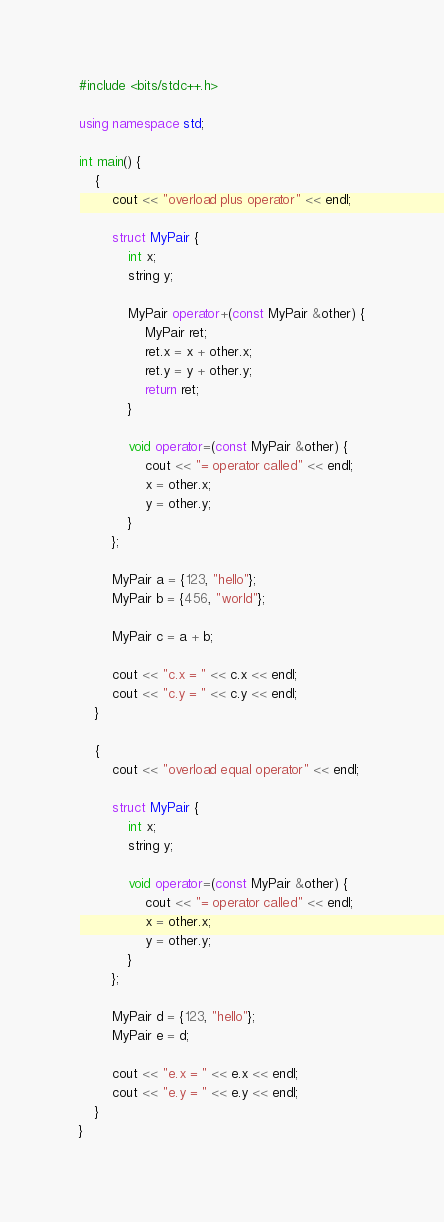<code> <loc_0><loc_0><loc_500><loc_500><_C++_>#include <bits/stdc++.h>

using namespace std;

int main() {
    {
        cout << "overload plus operator" << endl;

        struct MyPair {
            int x;
            string y;

            MyPair operator+(const MyPair &other) {
                MyPair ret;
                ret.x = x + other.x;
                ret.y = y + other.y;
                return ret;
            }

            void operator=(const MyPair &other) {
                cout << "= operator called" << endl;
                x = other.x;
                y = other.y;
            }
        };

        MyPair a = {123, "hello"};
        MyPair b = {456, "world"};

        MyPair c = a + b;

        cout << "c.x = " << c.x << endl;
        cout << "c.y = " << c.y << endl;
    }

    {
        cout << "overload equal operator" << endl;
        
        struct MyPair {
            int x;
            string y;

            void operator=(const MyPair &other) {
                cout << "= operator called" << endl;
                x = other.x;
                y = other.y;
            }
        };

        MyPair d = {123, "hello"};
        MyPair e = d;

        cout << "e.x = " << e.x << endl;
        cout << "e.y = " << e.y << endl;
    }
}</code> 